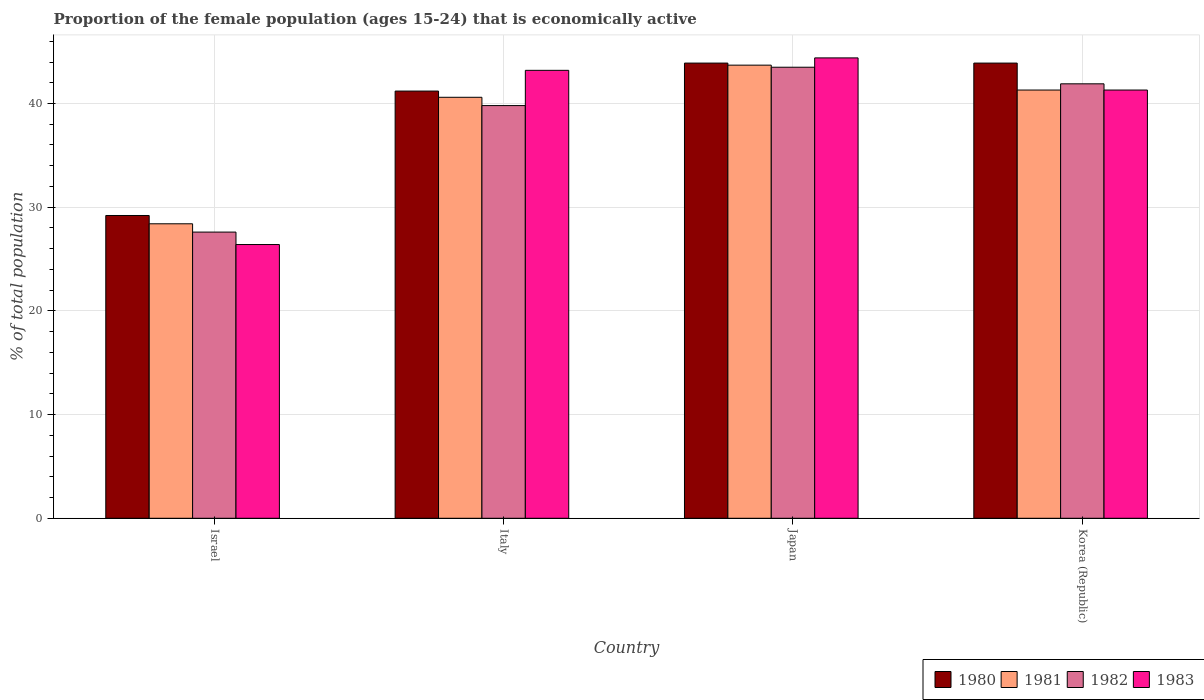How many groups of bars are there?
Ensure brevity in your answer.  4. Are the number of bars per tick equal to the number of legend labels?
Offer a very short reply. Yes. Are the number of bars on each tick of the X-axis equal?
Ensure brevity in your answer.  Yes. How many bars are there on the 4th tick from the left?
Ensure brevity in your answer.  4. How many bars are there on the 3rd tick from the right?
Offer a very short reply. 4. What is the proportion of the female population that is economically active in 1983 in Italy?
Keep it short and to the point. 43.2. Across all countries, what is the maximum proportion of the female population that is economically active in 1983?
Make the answer very short. 44.4. Across all countries, what is the minimum proportion of the female population that is economically active in 1981?
Ensure brevity in your answer.  28.4. In which country was the proportion of the female population that is economically active in 1982 maximum?
Make the answer very short. Japan. What is the total proportion of the female population that is economically active in 1982 in the graph?
Your answer should be very brief. 152.8. What is the difference between the proportion of the female population that is economically active in 1981 in Israel and that in Japan?
Keep it short and to the point. -15.3. What is the difference between the proportion of the female population that is economically active in 1983 in Israel and the proportion of the female population that is economically active in 1980 in Italy?
Your answer should be very brief. -14.8. What is the average proportion of the female population that is economically active in 1980 per country?
Keep it short and to the point. 39.55. What is the difference between the proportion of the female population that is economically active of/in 1981 and proportion of the female population that is economically active of/in 1983 in Korea (Republic)?
Your response must be concise. 0. In how many countries, is the proportion of the female population that is economically active in 1980 greater than 34 %?
Your response must be concise. 3. What is the ratio of the proportion of the female population that is economically active in 1983 in Japan to that in Korea (Republic)?
Ensure brevity in your answer.  1.08. Is the difference between the proportion of the female population that is economically active in 1981 in Israel and Japan greater than the difference between the proportion of the female population that is economically active in 1983 in Israel and Japan?
Provide a short and direct response. Yes. What is the difference between the highest and the second highest proportion of the female population that is economically active in 1983?
Provide a succinct answer. -1.9. What is the difference between the highest and the lowest proportion of the female population that is economically active in 1981?
Keep it short and to the point. 15.3. Is the sum of the proportion of the female population that is economically active in 1981 in Israel and Italy greater than the maximum proportion of the female population that is economically active in 1982 across all countries?
Offer a very short reply. Yes. What does the 2nd bar from the left in Italy represents?
Offer a very short reply. 1981. Is it the case that in every country, the sum of the proportion of the female population that is economically active in 1983 and proportion of the female population that is economically active in 1980 is greater than the proportion of the female population that is economically active in 1982?
Provide a succinct answer. Yes. What is the difference between two consecutive major ticks on the Y-axis?
Give a very brief answer. 10. Are the values on the major ticks of Y-axis written in scientific E-notation?
Your answer should be compact. No. Does the graph contain any zero values?
Provide a succinct answer. No. Does the graph contain grids?
Ensure brevity in your answer.  Yes. Where does the legend appear in the graph?
Your answer should be compact. Bottom right. What is the title of the graph?
Give a very brief answer. Proportion of the female population (ages 15-24) that is economically active. What is the label or title of the X-axis?
Offer a very short reply. Country. What is the label or title of the Y-axis?
Keep it short and to the point. % of total population. What is the % of total population of 1980 in Israel?
Provide a succinct answer. 29.2. What is the % of total population of 1981 in Israel?
Offer a very short reply. 28.4. What is the % of total population in 1982 in Israel?
Your response must be concise. 27.6. What is the % of total population in 1983 in Israel?
Give a very brief answer. 26.4. What is the % of total population in 1980 in Italy?
Provide a succinct answer. 41.2. What is the % of total population of 1981 in Italy?
Your answer should be very brief. 40.6. What is the % of total population in 1982 in Italy?
Ensure brevity in your answer.  39.8. What is the % of total population in 1983 in Italy?
Provide a short and direct response. 43.2. What is the % of total population of 1980 in Japan?
Provide a succinct answer. 43.9. What is the % of total population in 1981 in Japan?
Give a very brief answer. 43.7. What is the % of total population of 1982 in Japan?
Offer a terse response. 43.5. What is the % of total population of 1983 in Japan?
Ensure brevity in your answer.  44.4. What is the % of total population of 1980 in Korea (Republic)?
Give a very brief answer. 43.9. What is the % of total population in 1981 in Korea (Republic)?
Your answer should be compact. 41.3. What is the % of total population of 1982 in Korea (Republic)?
Make the answer very short. 41.9. What is the % of total population of 1983 in Korea (Republic)?
Offer a very short reply. 41.3. Across all countries, what is the maximum % of total population in 1980?
Make the answer very short. 43.9. Across all countries, what is the maximum % of total population in 1981?
Your response must be concise. 43.7. Across all countries, what is the maximum % of total population in 1982?
Give a very brief answer. 43.5. Across all countries, what is the maximum % of total population in 1983?
Offer a very short reply. 44.4. Across all countries, what is the minimum % of total population of 1980?
Keep it short and to the point. 29.2. Across all countries, what is the minimum % of total population of 1981?
Offer a very short reply. 28.4. Across all countries, what is the minimum % of total population of 1982?
Ensure brevity in your answer.  27.6. Across all countries, what is the minimum % of total population in 1983?
Provide a succinct answer. 26.4. What is the total % of total population in 1980 in the graph?
Ensure brevity in your answer.  158.2. What is the total % of total population of 1981 in the graph?
Keep it short and to the point. 154. What is the total % of total population of 1982 in the graph?
Offer a very short reply. 152.8. What is the total % of total population in 1983 in the graph?
Offer a very short reply. 155.3. What is the difference between the % of total population in 1982 in Israel and that in Italy?
Provide a succinct answer. -12.2. What is the difference between the % of total population in 1983 in Israel and that in Italy?
Your response must be concise. -16.8. What is the difference between the % of total population of 1980 in Israel and that in Japan?
Offer a terse response. -14.7. What is the difference between the % of total population of 1981 in Israel and that in Japan?
Your answer should be compact. -15.3. What is the difference between the % of total population of 1982 in Israel and that in Japan?
Give a very brief answer. -15.9. What is the difference between the % of total population of 1983 in Israel and that in Japan?
Your response must be concise. -18. What is the difference between the % of total population in 1980 in Israel and that in Korea (Republic)?
Offer a terse response. -14.7. What is the difference between the % of total population of 1982 in Israel and that in Korea (Republic)?
Your answer should be compact. -14.3. What is the difference between the % of total population of 1983 in Israel and that in Korea (Republic)?
Give a very brief answer. -14.9. What is the difference between the % of total population of 1980 in Italy and that in Japan?
Provide a succinct answer. -2.7. What is the difference between the % of total population in 1982 in Italy and that in Japan?
Your answer should be very brief. -3.7. What is the difference between the % of total population of 1983 in Italy and that in Japan?
Your answer should be compact. -1.2. What is the difference between the % of total population of 1981 in Japan and that in Korea (Republic)?
Give a very brief answer. 2.4. What is the difference between the % of total population in 1980 in Israel and the % of total population in 1981 in Italy?
Provide a short and direct response. -11.4. What is the difference between the % of total population of 1980 in Israel and the % of total population of 1982 in Italy?
Offer a terse response. -10.6. What is the difference between the % of total population of 1981 in Israel and the % of total population of 1982 in Italy?
Make the answer very short. -11.4. What is the difference between the % of total population of 1981 in Israel and the % of total population of 1983 in Italy?
Make the answer very short. -14.8. What is the difference between the % of total population in 1982 in Israel and the % of total population in 1983 in Italy?
Provide a succinct answer. -15.6. What is the difference between the % of total population of 1980 in Israel and the % of total population of 1982 in Japan?
Offer a terse response. -14.3. What is the difference between the % of total population of 1980 in Israel and the % of total population of 1983 in Japan?
Your response must be concise. -15.2. What is the difference between the % of total population in 1981 in Israel and the % of total population in 1982 in Japan?
Offer a very short reply. -15.1. What is the difference between the % of total population in 1982 in Israel and the % of total population in 1983 in Japan?
Make the answer very short. -16.8. What is the difference between the % of total population in 1980 in Israel and the % of total population in 1983 in Korea (Republic)?
Keep it short and to the point. -12.1. What is the difference between the % of total population in 1981 in Israel and the % of total population in 1983 in Korea (Republic)?
Your answer should be very brief. -12.9. What is the difference between the % of total population of 1982 in Israel and the % of total population of 1983 in Korea (Republic)?
Offer a very short reply. -13.7. What is the difference between the % of total population in 1982 in Italy and the % of total population in 1983 in Japan?
Your answer should be very brief. -4.6. What is the difference between the % of total population in 1980 in Italy and the % of total population in 1981 in Korea (Republic)?
Give a very brief answer. -0.1. What is the difference between the % of total population of 1981 in Italy and the % of total population of 1983 in Korea (Republic)?
Make the answer very short. -0.7. What is the difference between the % of total population in 1982 in Italy and the % of total population in 1983 in Korea (Republic)?
Your answer should be compact. -1.5. What is the difference between the % of total population in 1980 in Japan and the % of total population in 1983 in Korea (Republic)?
Provide a short and direct response. 2.6. What is the difference between the % of total population in 1981 in Japan and the % of total population in 1982 in Korea (Republic)?
Offer a very short reply. 1.8. What is the difference between the % of total population in 1981 in Japan and the % of total population in 1983 in Korea (Republic)?
Give a very brief answer. 2.4. What is the average % of total population of 1980 per country?
Make the answer very short. 39.55. What is the average % of total population of 1981 per country?
Your response must be concise. 38.5. What is the average % of total population in 1982 per country?
Your answer should be compact. 38.2. What is the average % of total population of 1983 per country?
Provide a short and direct response. 38.83. What is the difference between the % of total population in 1980 and % of total population in 1982 in Israel?
Give a very brief answer. 1.6. What is the difference between the % of total population in 1981 and % of total population in 1982 in Israel?
Offer a terse response. 0.8. What is the difference between the % of total population in 1981 and % of total population in 1983 in Israel?
Your answer should be compact. 2. What is the difference between the % of total population in 1981 and % of total population in 1982 in Italy?
Your answer should be very brief. 0.8. What is the difference between the % of total population in 1980 and % of total population in 1981 in Japan?
Your answer should be compact. 0.2. What is the difference between the % of total population of 1980 and % of total population of 1983 in Japan?
Keep it short and to the point. -0.5. What is the difference between the % of total population in 1981 and % of total population in 1983 in Japan?
Ensure brevity in your answer.  -0.7. What is the difference between the % of total population of 1982 and % of total population of 1983 in Japan?
Provide a short and direct response. -0.9. What is the difference between the % of total population of 1980 and % of total population of 1981 in Korea (Republic)?
Your answer should be compact. 2.6. What is the difference between the % of total population in 1980 and % of total population in 1983 in Korea (Republic)?
Make the answer very short. 2.6. What is the difference between the % of total population of 1981 and % of total population of 1982 in Korea (Republic)?
Offer a terse response. -0.6. What is the difference between the % of total population of 1981 and % of total population of 1983 in Korea (Republic)?
Make the answer very short. 0. What is the ratio of the % of total population in 1980 in Israel to that in Italy?
Keep it short and to the point. 0.71. What is the ratio of the % of total population in 1981 in Israel to that in Italy?
Offer a terse response. 0.7. What is the ratio of the % of total population of 1982 in Israel to that in Italy?
Make the answer very short. 0.69. What is the ratio of the % of total population of 1983 in Israel to that in Italy?
Offer a terse response. 0.61. What is the ratio of the % of total population of 1980 in Israel to that in Japan?
Your answer should be compact. 0.67. What is the ratio of the % of total population of 1981 in Israel to that in Japan?
Keep it short and to the point. 0.65. What is the ratio of the % of total population of 1982 in Israel to that in Japan?
Provide a succinct answer. 0.63. What is the ratio of the % of total population in 1983 in Israel to that in Japan?
Your answer should be very brief. 0.59. What is the ratio of the % of total population of 1980 in Israel to that in Korea (Republic)?
Make the answer very short. 0.67. What is the ratio of the % of total population in 1981 in Israel to that in Korea (Republic)?
Provide a succinct answer. 0.69. What is the ratio of the % of total population in 1982 in Israel to that in Korea (Republic)?
Provide a short and direct response. 0.66. What is the ratio of the % of total population in 1983 in Israel to that in Korea (Republic)?
Give a very brief answer. 0.64. What is the ratio of the % of total population in 1980 in Italy to that in Japan?
Your answer should be compact. 0.94. What is the ratio of the % of total population in 1981 in Italy to that in Japan?
Make the answer very short. 0.93. What is the ratio of the % of total population of 1982 in Italy to that in Japan?
Keep it short and to the point. 0.91. What is the ratio of the % of total population of 1980 in Italy to that in Korea (Republic)?
Your answer should be compact. 0.94. What is the ratio of the % of total population in 1981 in Italy to that in Korea (Republic)?
Your response must be concise. 0.98. What is the ratio of the % of total population in 1982 in Italy to that in Korea (Republic)?
Make the answer very short. 0.95. What is the ratio of the % of total population of 1983 in Italy to that in Korea (Republic)?
Make the answer very short. 1.05. What is the ratio of the % of total population in 1980 in Japan to that in Korea (Republic)?
Offer a very short reply. 1. What is the ratio of the % of total population in 1981 in Japan to that in Korea (Republic)?
Offer a terse response. 1.06. What is the ratio of the % of total population of 1982 in Japan to that in Korea (Republic)?
Your answer should be very brief. 1.04. What is the ratio of the % of total population in 1983 in Japan to that in Korea (Republic)?
Ensure brevity in your answer.  1.08. What is the difference between the highest and the second highest % of total population of 1981?
Provide a short and direct response. 2.4. What is the difference between the highest and the second highest % of total population of 1982?
Provide a short and direct response. 1.6. What is the difference between the highest and the second highest % of total population in 1983?
Your response must be concise. 1.2. What is the difference between the highest and the lowest % of total population of 1983?
Your answer should be compact. 18. 